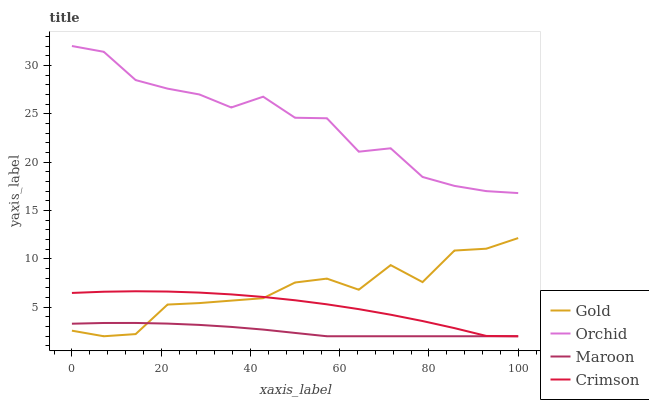Does Maroon have the minimum area under the curve?
Answer yes or no. Yes. Does Orchid have the maximum area under the curve?
Answer yes or no. Yes. Does Gold have the minimum area under the curve?
Answer yes or no. No. Does Gold have the maximum area under the curve?
Answer yes or no. No. Is Maroon the smoothest?
Answer yes or no. Yes. Is Gold the roughest?
Answer yes or no. Yes. Is Gold the smoothest?
Answer yes or no. No. Is Maroon the roughest?
Answer yes or no. No. Does Crimson have the lowest value?
Answer yes or no. Yes. Does Orchid have the lowest value?
Answer yes or no. No. Does Orchid have the highest value?
Answer yes or no. Yes. Does Gold have the highest value?
Answer yes or no. No. Is Gold less than Orchid?
Answer yes or no. Yes. Is Orchid greater than Gold?
Answer yes or no. Yes. Does Crimson intersect Gold?
Answer yes or no. Yes. Is Crimson less than Gold?
Answer yes or no. No. Is Crimson greater than Gold?
Answer yes or no. No. Does Gold intersect Orchid?
Answer yes or no. No. 